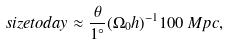<formula> <loc_0><loc_0><loc_500><loc_500>s i z e t o d a y \approx \frac { \theta } { 1 ^ { \circ } } ( \Omega _ { 0 } h ) ^ { - 1 } 1 0 0 \, M p c ,</formula> 